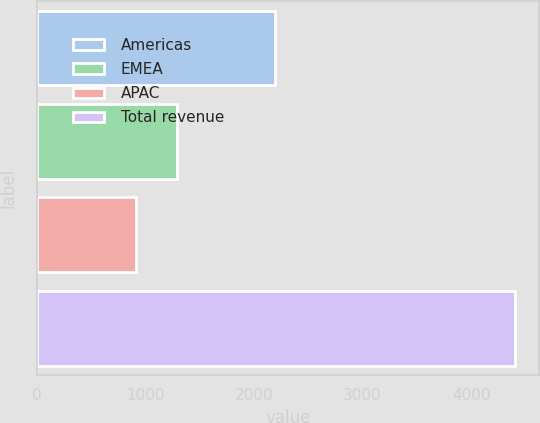Convert chart. <chart><loc_0><loc_0><loc_500><loc_500><bar_chart><fcel>Americas<fcel>EMEA<fcel>APAC<fcel>Total revenue<nl><fcel>2196.4<fcel>1294.6<fcel>912.7<fcel>4403.7<nl></chart> 